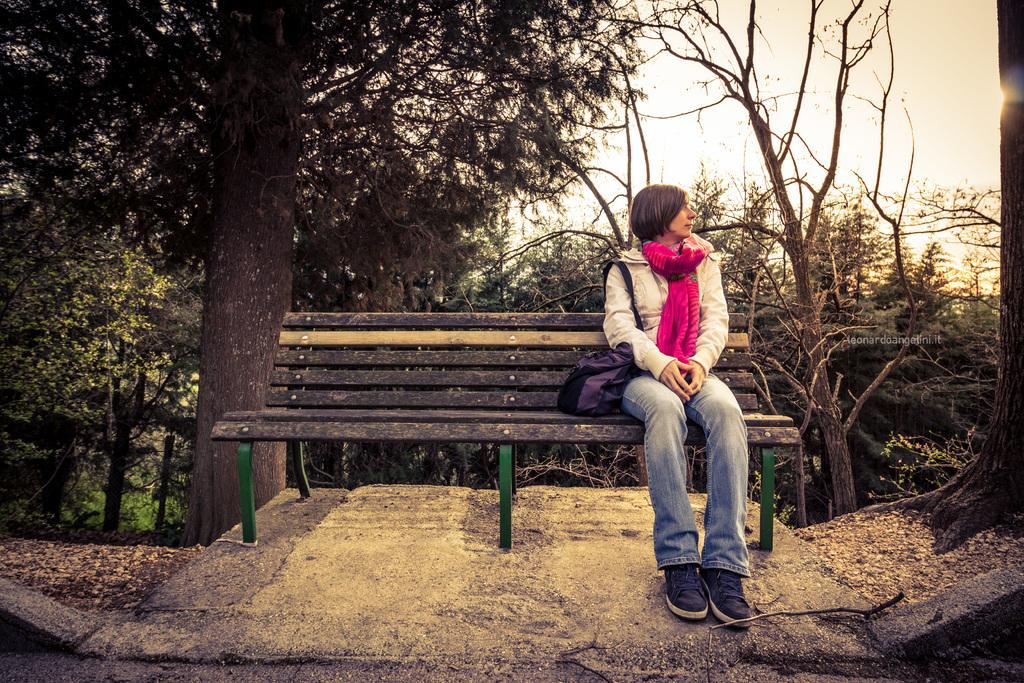How would you summarize this image in a sentence or two? This image consists of a bench on which a person is sitting. She is hanging a bag to her shoulder. She is wearing a scarf, there are trees in the back side. 